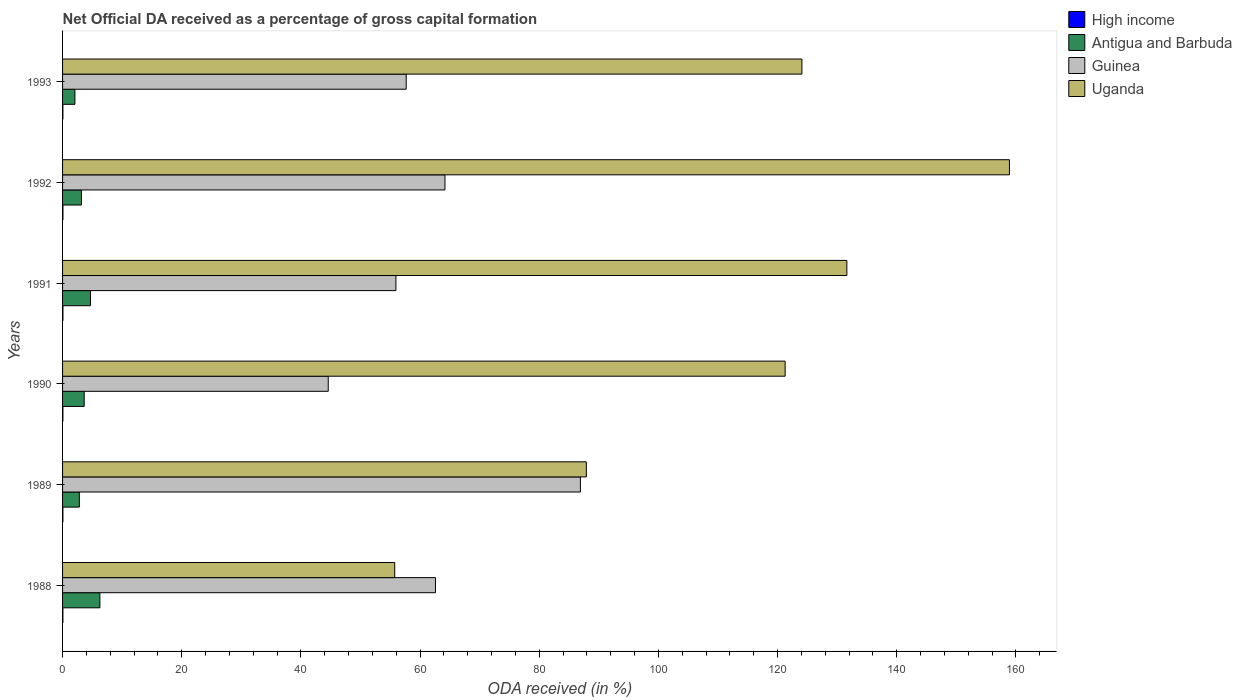How many different coloured bars are there?
Ensure brevity in your answer.  4. Are the number of bars per tick equal to the number of legend labels?
Provide a succinct answer. Yes. Are the number of bars on each tick of the Y-axis equal?
Give a very brief answer. Yes. How many bars are there on the 5th tick from the bottom?
Keep it short and to the point. 4. What is the net ODA received in High income in 1990?
Your answer should be very brief. 0.06. Across all years, what is the maximum net ODA received in Antigua and Barbuda?
Make the answer very short. 6.26. Across all years, what is the minimum net ODA received in Antigua and Barbuda?
Offer a very short reply. 2.07. In which year was the net ODA received in Uganda maximum?
Your answer should be very brief. 1992. What is the total net ODA received in High income in the graph?
Provide a short and direct response. 0.35. What is the difference between the net ODA received in Uganda in 1990 and that in 1992?
Offer a terse response. -37.64. What is the difference between the net ODA received in Antigua and Barbuda in 1993 and the net ODA received in Uganda in 1989?
Your answer should be compact. -85.83. What is the average net ODA received in Uganda per year?
Offer a very short reply. 113.25. In the year 1993, what is the difference between the net ODA received in Uganda and net ODA received in Antigua and Barbuda?
Provide a short and direct response. 122. In how many years, is the net ODA received in Antigua and Barbuda greater than 100 %?
Provide a succinct answer. 0. What is the ratio of the net ODA received in High income in 1988 to that in 1991?
Offer a very short reply. 0.93. What is the difference between the highest and the second highest net ODA received in Antigua and Barbuda?
Ensure brevity in your answer.  1.58. What is the difference between the highest and the lowest net ODA received in Antigua and Barbuda?
Make the answer very short. 4.19. Is the sum of the net ODA received in Guinea in 1989 and 1993 greater than the maximum net ODA received in Uganda across all years?
Give a very brief answer. No. Is it the case that in every year, the sum of the net ODA received in Uganda and net ODA received in Antigua and Barbuda is greater than the sum of net ODA received in High income and net ODA received in Guinea?
Provide a succinct answer. Yes. What does the 2nd bar from the top in 1989 represents?
Your response must be concise. Guinea. Is it the case that in every year, the sum of the net ODA received in Guinea and net ODA received in Uganda is greater than the net ODA received in High income?
Your answer should be compact. Yes. Are all the bars in the graph horizontal?
Give a very brief answer. Yes. What is the difference between two consecutive major ticks on the X-axis?
Your answer should be compact. 20. Are the values on the major ticks of X-axis written in scientific E-notation?
Offer a terse response. No. Does the graph contain any zero values?
Your response must be concise. No. Where does the legend appear in the graph?
Your answer should be compact. Top right. How many legend labels are there?
Your response must be concise. 4. What is the title of the graph?
Provide a succinct answer. Net Official DA received as a percentage of gross capital formation. What is the label or title of the X-axis?
Keep it short and to the point. ODA received (in %). What is the label or title of the Y-axis?
Offer a terse response. Years. What is the ODA received (in %) of High income in 1988?
Your answer should be compact. 0.06. What is the ODA received (in %) of Antigua and Barbuda in 1988?
Your response must be concise. 6.26. What is the ODA received (in %) in Guinea in 1988?
Your answer should be compact. 62.58. What is the ODA received (in %) in Uganda in 1988?
Offer a very short reply. 55.74. What is the ODA received (in %) in High income in 1989?
Ensure brevity in your answer.  0.06. What is the ODA received (in %) in Antigua and Barbuda in 1989?
Your answer should be compact. 2.82. What is the ODA received (in %) of Guinea in 1989?
Your answer should be compact. 86.9. What is the ODA received (in %) in Uganda in 1989?
Provide a succinct answer. 87.9. What is the ODA received (in %) in High income in 1990?
Your answer should be very brief. 0.06. What is the ODA received (in %) in Antigua and Barbuda in 1990?
Offer a terse response. 3.63. What is the ODA received (in %) of Guinea in 1990?
Make the answer very short. 44.58. What is the ODA received (in %) in Uganda in 1990?
Provide a short and direct response. 121.26. What is the ODA received (in %) in High income in 1991?
Make the answer very short. 0.06. What is the ODA received (in %) of Antigua and Barbuda in 1991?
Your answer should be very brief. 4.68. What is the ODA received (in %) in Guinea in 1991?
Your answer should be compact. 55.94. What is the ODA received (in %) of Uganda in 1991?
Offer a very short reply. 131.62. What is the ODA received (in %) in High income in 1992?
Provide a short and direct response. 0.06. What is the ODA received (in %) in Antigua and Barbuda in 1992?
Your response must be concise. 3.17. What is the ODA received (in %) of Guinea in 1992?
Provide a short and direct response. 64.17. What is the ODA received (in %) in Uganda in 1992?
Offer a very short reply. 158.9. What is the ODA received (in %) of High income in 1993?
Your answer should be compact. 0.06. What is the ODA received (in %) of Antigua and Barbuda in 1993?
Provide a short and direct response. 2.07. What is the ODA received (in %) in Guinea in 1993?
Your answer should be very brief. 57.67. What is the ODA received (in %) of Uganda in 1993?
Provide a succinct answer. 124.08. Across all years, what is the maximum ODA received (in %) of High income?
Make the answer very short. 0.06. Across all years, what is the maximum ODA received (in %) of Antigua and Barbuda?
Your response must be concise. 6.26. Across all years, what is the maximum ODA received (in %) of Guinea?
Make the answer very short. 86.9. Across all years, what is the maximum ODA received (in %) of Uganda?
Your answer should be compact. 158.9. Across all years, what is the minimum ODA received (in %) of High income?
Make the answer very short. 0.06. Across all years, what is the minimum ODA received (in %) of Antigua and Barbuda?
Your response must be concise. 2.07. Across all years, what is the minimum ODA received (in %) in Guinea?
Keep it short and to the point. 44.58. Across all years, what is the minimum ODA received (in %) in Uganda?
Provide a succinct answer. 55.74. What is the total ODA received (in %) in High income in the graph?
Offer a terse response. 0.35. What is the total ODA received (in %) of Antigua and Barbuda in the graph?
Give a very brief answer. 22.64. What is the total ODA received (in %) of Guinea in the graph?
Keep it short and to the point. 371.85. What is the total ODA received (in %) of Uganda in the graph?
Offer a very short reply. 679.5. What is the difference between the ODA received (in %) in High income in 1988 and that in 1989?
Give a very brief answer. 0. What is the difference between the ODA received (in %) of Antigua and Barbuda in 1988 and that in 1989?
Ensure brevity in your answer.  3.44. What is the difference between the ODA received (in %) of Guinea in 1988 and that in 1989?
Offer a terse response. -24.32. What is the difference between the ODA received (in %) in Uganda in 1988 and that in 1989?
Provide a short and direct response. -32.15. What is the difference between the ODA received (in %) of High income in 1988 and that in 1990?
Make the answer very short. -0. What is the difference between the ODA received (in %) in Antigua and Barbuda in 1988 and that in 1990?
Ensure brevity in your answer.  2.63. What is the difference between the ODA received (in %) of Guinea in 1988 and that in 1990?
Provide a short and direct response. 18. What is the difference between the ODA received (in %) of Uganda in 1988 and that in 1990?
Your response must be concise. -65.52. What is the difference between the ODA received (in %) of High income in 1988 and that in 1991?
Provide a short and direct response. -0. What is the difference between the ODA received (in %) in Antigua and Barbuda in 1988 and that in 1991?
Your answer should be compact. 1.58. What is the difference between the ODA received (in %) of Guinea in 1988 and that in 1991?
Your answer should be compact. 6.64. What is the difference between the ODA received (in %) in Uganda in 1988 and that in 1991?
Your answer should be compact. -75.87. What is the difference between the ODA received (in %) in High income in 1988 and that in 1992?
Your answer should be compact. -0.01. What is the difference between the ODA received (in %) in Antigua and Barbuda in 1988 and that in 1992?
Provide a short and direct response. 3.1. What is the difference between the ODA received (in %) in Guinea in 1988 and that in 1992?
Give a very brief answer. -1.59. What is the difference between the ODA received (in %) of Uganda in 1988 and that in 1992?
Your answer should be very brief. -103.16. What is the difference between the ODA received (in %) of High income in 1988 and that in 1993?
Your answer should be very brief. -0. What is the difference between the ODA received (in %) in Antigua and Barbuda in 1988 and that in 1993?
Your response must be concise. 4.19. What is the difference between the ODA received (in %) of Guinea in 1988 and that in 1993?
Your answer should be very brief. 4.91. What is the difference between the ODA received (in %) of Uganda in 1988 and that in 1993?
Your response must be concise. -68.33. What is the difference between the ODA received (in %) of High income in 1989 and that in 1990?
Your answer should be compact. -0. What is the difference between the ODA received (in %) in Antigua and Barbuda in 1989 and that in 1990?
Your response must be concise. -0.81. What is the difference between the ODA received (in %) in Guinea in 1989 and that in 1990?
Give a very brief answer. 42.32. What is the difference between the ODA received (in %) in Uganda in 1989 and that in 1990?
Provide a short and direct response. -33.36. What is the difference between the ODA received (in %) of High income in 1989 and that in 1991?
Make the answer very short. -0.01. What is the difference between the ODA received (in %) of Antigua and Barbuda in 1989 and that in 1991?
Provide a succinct answer. -1.87. What is the difference between the ODA received (in %) in Guinea in 1989 and that in 1991?
Ensure brevity in your answer.  30.96. What is the difference between the ODA received (in %) in Uganda in 1989 and that in 1991?
Keep it short and to the point. -43.72. What is the difference between the ODA received (in %) in High income in 1989 and that in 1992?
Give a very brief answer. -0.01. What is the difference between the ODA received (in %) in Antigua and Barbuda in 1989 and that in 1992?
Offer a very short reply. -0.35. What is the difference between the ODA received (in %) in Guinea in 1989 and that in 1992?
Offer a very short reply. 22.73. What is the difference between the ODA received (in %) in Uganda in 1989 and that in 1992?
Your response must be concise. -71. What is the difference between the ODA received (in %) of High income in 1989 and that in 1993?
Provide a short and direct response. -0. What is the difference between the ODA received (in %) in Antigua and Barbuda in 1989 and that in 1993?
Offer a terse response. 0.74. What is the difference between the ODA received (in %) in Guinea in 1989 and that in 1993?
Ensure brevity in your answer.  29.23. What is the difference between the ODA received (in %) of Uganda in 1989 and that in 1993?
Your answer should be very brief. -36.18. What is the difference between the ODA received (in %) in High income in 1990 and that in 1991?
Offer a very short reply. -0. What is the difference between the ODA received (in %) in Antigua and Barbuda in 1990 and that in 1991?
Your answer should be very brief. -1.06. What is the difference between the ODA received (in %) of Guinea in 1990 and that in 1991?
Ensure brevity in your answer.  -11.36. What is the difference between the ODA received (in %) in Uganda in 1990 and that in 1991?
Your answer should be compact. -10.36. What is the difference between the ODA received (in %) of High income in 1990 and that in 1992?
Provide a succinct answer. -0.01. What is the difference between the ODA received (in %) in Antigua and Barbuda in 1990 and that in 1992?
Your answer should be compact. 0.46. What is the difference between the ODA received (in %) in Guinea in 1990 and that in 1992?
Offer a very short reply. -19.59. What is the difference between the ODA received (in %) of Uganda in 1990 and that in 1992?
Offer a very short reply. -37.64. What is the difference between the ODA received (in %) of Antigua and Barbuda in 1990 and that in 1993?
Your answer should be very brief. 1.56. What is the difference between the ODA received (in %) in Guinea in 1990 and that in 1993?
Your answer should be very brief. -13.09. What is the difference between the ODA received (in %) in Uganda in 1990 and that in 1993?
Ensure brevity in your answer.  -2.81. What is the difference between the ODA received (in %) of High income in 1991 and that in 1992?
Ensure brevity in your answer.  -0. What is the difference between the ODA received (in %) in Antigua and Barbuda in 1991 and that in 1992?
Provide a succinct answer. 1.52. What is the difference between the ODA received (in %) in Guinea in 1991 and that in 1992?
Your answer should be very brief. -8.23. What is the difference between the ODA received (in %) in Uganda in 1991 and that in 1992?
Keep it short and to the point. -27.29. What is the difference between the ODA received (in %) of High income in 1991 and that in 1993?
Make the answer very short. 0. What is the difference between the ODA received (in %) in Antigua and Barbuda in 1991 and that in 1993?
Your response must be concise. 2.61. What is the difference between the ODA received (in %) in Guinea in 1991 and that in 1993?
Make the answer very short. -1.73. What is the difference between the ODA received (in %) in Uganda in 1991 and that in 1993?
Give a very brief answer. 7.54. What is the difference between the ODA received (in %) in High income in 1992 and that in 1993?
Keep it short and to the point. 0.01. What is the difference between the ODA received (in %) in Antigua and Barbuda in 1992 and that in 1993?
Keep it short and to the point. 1.09. What is the difference between the ODA received (in %) of Guinea in 1992 and that in 1993?
Provide a succinct answer. 6.5. What is the difference between the ODA received (in %) in Uganda in 1992 and that in 1993?
Your response must be concise. 34.83. What is the difference between the ODA received (in %) in High income in 1988 and the ODA received (in %) in Antigua and Barbuda in 1989?
Keep it short and to the point. -2.76. What is the difference between the ODA received (in %) in High income in 1988 and the ODA received (in %) in Guinea in 1989?
Your answer should be compact. -86.85. What is the difference between the ODA received (in %) of High income in 1988 and the ODA received (in %) of Uganda in 1989?
Provide a succinct answer. -87.84. What is the difference between the ODA received (in %) of Antigua and Barbuda in 1988 and the ODA received (in %) of Guinea in 1989?
Give a very brief answer. -80.64. What is the difference between the ODA received (in %) in Antigua and Barbuda in 1988 and the ODA received (in %) in Uganda in 1989?
Make the answer very short. -81.64. What is the difference between the ODA received (in %) in Guinea in 1988 and the ODA received (in %) in Uganda in 1989?
Give a very brief answer. -25.32. What is the difference between the ODA received (in %) in High income in 1988 and the ODA received (in %) in Antigua and Barbuda in 1990?
Provide a short and direct response. -3.57. What is the difference between the ODA received (in %) in High income in 1988 and the ODA received (in %) in Guinea in 1990?
Give a very brief answer. -44.53. What is the difference between the ODA received (in %) of High income in 1988 and the ODA received (in %) of Uganda in 1990?
Provide a short and direct response. -121.2. What is the difference between the ODA received (in %) of Antigua and Barbuda in 1988 and the ODA received (in %) of Guinea in 1990?
Your answer should be very brief. -38.32. What is the difference between the ODA received (in %) of Antigua and Barbuda in 1988 and the ODA received (in %) of Uganda in 1990?
Provide a succinct answer. -115. What is the difference between the ODA received (in %) of Guinea in 1988 and the ODA received (in %) of Uganda in 1990?
Provide a succinct answer. -58.68. What is the difference between the ODA received (in %) in High income in 1988 and the ODA received (in %) in Antigua and Barbuda in 1991?
Offer a very short reply. -4.63. What is the difference between the ODA received (in %) of High income in 1988 and the ODA received (in %) of Guinea in 1991?
Ensure brevity in your answer.  -55.88. What is the difference between the ODA received (in %) in High income in 1988 and the ODA received (in %) in Uganda in 1991?
Give a very brief answer. -131.56. What is the difference between the ODA received (in %) of Antigua and Barbuda in 1988 and the ODA received (in %) of Guinea in 1991?
Your answer should be compact. -49.68. What is the difference between the ODA received (in %) of Antigua and Barbuda in 1988 and the ODA received (in %) of Uganda in 1991?
Offer a very short reply. -125.35. What is the difference between the ODA received (in %) of Guinea in 1988 and the ODA received (in %) of Uganda in 1991?
Your response must be concise. -69.04. What is the difference between the ODA received (in %) in High income in 1988 and the ODA received (in %) in Antigua and Barbuda in 1992?
Offer a terse response. -3.11. What is the difference between the ODA received (in %) of High income in 1988 and the ODA received (in %) of Guinea in 1992?
Give a very brief answer. -64.11. What is the difference between the ODA received (in %) in High income in 1988 and the ODA received (in %) in Uganda in 1992?
Your answer should be compact. -158.85. What is the difference between the ODA received (in %) in Antigua and Barbuda in 1988 and the ODA received (in %) in Guinea in 1992?
Provide a short and direct response. -57.91. What is the difference between the ODA received (in %) of Antigua and Barbuda in 1988 and the ODA received (in %) of Uganda in 1992?
Offer a terse response. -152.64. What is the difference between the ODA received (in %) of Guinea in 1988 and the ODA received (in %) of Uganda in 1992?
Provide a succinct answer. -96.32. What is the difference between the ODA received (in %) in High income in 1988 and the ODA received (in %) in Antigua and Barbuda in 1993?
Provide a short and direct response. -2.02. What is the difference between the ODA received (in %) in High income in 1988 and the ODA received (in %) in Guinea in 1993?
Offer a very short reply. -57.61. What is the difference between the ODA received (in %) of High income in 1988 and the ODA received (in %) of Uganda in 1993?
Your answer should be compact. -124.02. What is the difference between the ODA received (in %) in Antigua and Barbuda in 1988 and the ODA received (in %) in Guinea in 1993?
Make the answer very short. -51.41. What is the difference between the ODA received (in %) in Antigua and Barbuda in 1988 and the ODA received (in %) in Uganda in 1993?
Your response must be concise. -117.81. What is the difference between the ODA received (in %) of Guinea in 1988 and the ODA received (in %) of Uganda in 1993?
Offer a terse response. -61.5. What is the difference between the ODA received (in %) of High income in 1989 and the ODA received (in %) of Antigua and Barbuda in 1990?
Provide a short and direct response. -3.57. What is the difference between the ODA received (in %) of High income in 1989 and the ODA received (in %) of Guinea in 1990?
Your response must be concise. -44.53. What is the difference between the ODA received (in %) of High income in 1989 and the ODA received (in %) of Uganda in 1990?
Ensure brevity in your answer.  -121.21. What is the difference between the ODA received (in %) of Antigua and Barbuda in 1989 and the ODA received (in %) of Guinea in 1990?
Give a very brief answer. -41.77. What is the difference between the ODA received (in %) of Antigua and Barbuda in 1989 and the ODA received (in %) of Uganda in 1990?
Give a very brief answer. -118.44. What is the difference between the ODA received (in %) of Guinea in 1989 and the ODA received (in %) of Uganda in 1990?
Provide a succinct answer. -34.36. What is the difference between the ODA received (in %) of High income in 1989 and the ODA received (in %) of Antigua and Barbuda in 1991?
Offer a very short reply. -4.63. What is the difference between the ODA received (in %) in High income in 1989 and the ODA received (in %) in Guinea in 1991?
Offer a very short reply. -55.88. What is the difference between the ODA received (in %) of High income in 1989 and the ODA received (in %) of Uganda in 1991?
Provide a short and direct response. -131.56. What is the difference between the ODA received (in %) of Antigua and Barbuda in 1989 and the ODA received (in %) of Guinea in 1991?
Ensure brevity in your answer.  -53.12. What is the difference between the ODA received (in %) of Antigua and Barbuda in 1989 and the ODA received (in %) of Uganda in 1991?
Make the answer very short. -128.8. What is the difference between the ODA received (in %) in Guinea in 1989 and the ODA received (in %) in Uganda in 1991?
Give a very brief answer. -44.71. What is the difference between the ODA received (in %) in High income in 1989 and the ODA received (in %) in Antigua and Barbuda in 1992?
Offer a very short reply. -3.11. What is the difference between the ODA received (in %) of High income in 1989 and the ODA received (in %) of Guinea in 1992?
Keep it short and to the point. -64.12. What is the difference between the ODA received (in %) of High income in 1989 and the ODA received (in %) of Uganda in 1992?
Provide a short and direct response. -158.85. What is the difference between the ODA received (in %) in Antigua and Barbuda in 1989 and the ODA received (in %) in Guinea in 1992?
Your answer should be very brief. -61.35. What is the difference between the ODA received (in %) of Antigua and Barbuda in 1989 and the ODA received (in %) of Uganda in 1992?
Give a very brief answer. -156.09. What is the difference between the ODA received (in %) of Guinea in 1989 and the ODA received (in %) of Uganda in 1992?
Keep it short and to the point. -72. What is the difference between the ODA received (in %) in High income in 1989 and the ODA received (in %) in Antigua and Barbuda in 1993?
Offer a terse response. -2.02. What is the difference between the ODA received (in %) in High income in 1989 and the ODA received (in %) in Guinea in 1993?
Offer a very short reply. -57.61. What is the difference between the ODA received (in %) of High income in 1989 and the ODA received (in %) of Uganda in 1993?
Offer a terse response. -124.02. What is the difference between the ODA received (in %) of Antigua and Barbuda in 1989 and the ODA received (in %) of Guinea in 1993?
Your answer should be very brief. -54.85. What is the difference between the ODA received (in %) of Antigua and Barbuda in 1989 and the ODA received (in %) of Uganda in 1993?
Offer a terse response. -121.26. What is the difference between the ODA received (in %) in Guinea in 1989 and the ODA received (in %) in Uganda in 1993?
Give a very brief answer. -37.17. What is the difference between the ODA received (in %) of High income in 1990 and the ODA received (in %) of Antigua and Barbuda in 1991?
Make the answer very short. -4.63. What is the difference between the ODA received (in %) in High income in 1990 and the ODA received (in %) in Guinea in 1991?
Offer a very short reply. -55.88. What is the difference between the ODA received (in %) of High income in 1990 and the ODA received (in %) of Uganda in 1991?
Provide a succinct answer. -131.56. What is the difference between the ODA received (in %) in Antigua and Barbuda in 1990 and the ODA received (in %) in Guinea in 1991?
Ensure brevity in your answer.  -52.31. What is the difference between the ODA received (in %) in Antigua and Barbuda in 1990 and the ODA received (in %) in Uganda in 1991?
Offer a very short reply. -127.99. What is the difference between the ODA received (in %) in Guinea in 1990 and the ODA received (in %) in Uganda in 1991?
Your answer should be compact. -87.03. What is the difference between the ODA received (in %) of High income in 1990 and the ODA received (in %) of Antigua and Barbuda in 1992?
Make the answer very short. -3.11. What is the difference between the ODA received (in %) in High income in 1990 and the ODA received (in %) in Guinea in 1992?
Keep it short and to the point. -64.11. What is the difference between the ODA received (in %) of High income in 1990 and the ODA received (in %) of Uganda in 1992?
Ensure brevity in your answer.  -158.85. What is the difference between the ODA received (in %) in Antigua and Barbuda in 1990 and the ODA received (in %) in Guinea in 1992?
Offer a terse response. -60.54. What is the difference between the ODA received (in %) in Antigua and Barbuda in 1990 and the ODA received (in %) in Uganda in 1992?
Make the answer very short. -155.27. What is the difference between the ODA received (in %) of Guinea in 1990 and the ODA received (in %) of Uganda in 1992?
Provide a succinct answer. -114.32. What is the difference between the ODA received (in %) of High income in 1990 and the ODA received (in %) of Antigua and Barbuda in 1993?
Provide a short and direct response. -2.02. What is the difference between the ODA received (in %) of High income in 1990 and the ODA received (in %) of Guinea in 1993?
Your answer should be very brief. -57.61. What is the difference between the ODA received (in %) of High income in 1990 and the ODA received (in %) of Uganda in 1993?
Provide a succinct answer. -124.02. What is the difference between the ODA received (in %) in Antigua and Barbuda in 1990 and the ODA received (in %) in Guinea in 1993?
Your response must be concise. -54.04. What is the difference between the ODA received (in %) in Antigua and Barbuda in 1990 and the ODA received (in %) in Uganda in 1993?
Provide a short and direct response. -120.45. What is the difference between the ODA received (in %) of Guinea in 1990 and the ODA received (in %) of Uganda in 1993?
Offer a very short reply. -79.49. What is the difference between the ODA received (in %) in High income in 1991 and the ODA received (in %) in Antigua and Barbuda in 1992?
Your answer should be very brief. -3.11. What is the difference between the ODA received (in %) of High income in 1991 and the ODA received (in %) of Guinea in 1992?
Your answer should be compact. -64.11. What is the difference between the ODA received (in %) in High income in 1991 and the ODA received (in %) in Uganda in 1992?
Keep it short and to the point. -158.84. What is the difference between the ODA received (in %) in Antigua and Barbuda in 1991 and the ODA received (in %) in Guinea in 1992?
Make the answer very short. -59.49. What is the difference between the ODA received (in %) in Antigua and Barbuda in 1991 and the ODA received (in %) in Uganda in 1992?
Offer a very short reply. -154.22. What is the difference between the ODA received (in %) in Guinea in 1991 and the ODA received (in %) in Uganda in 1992?
Offer a very short reply. -102.96. What is the difference between the ODA received (in %) in High income in 1991 and the ODA received (in %) in Antigua and Barbuda in 1993?
Your answer should be compact. -2.01. What is the difference between the ODA received (in %) in High income in 1991 and the ODA received (in %) in Guinea in 1993?
Offer a terse response. -57.61. What is the difference between the ODA received (in %) of High income in 1991 and the ODA received (in %) of Uganda in 1993?
Your answer should be very brief. -124.01. What is the difference between the ODA received (in %) of Antigua and Barbuda in 1991 and the ODA received (in %) of Guinea in 1993?
Offer a terse response. -52.99. What is the difference between the ODA received (in %) of Antigua and Barbuda in 1991 and the ODA received (in %) of Uganda in 1993?
Your response must be concise. -119.39. What is the difference between the ODA received (in %) of Guinea in 1991 and the ODA received (in %) of Uganda in 1993?
Provide a short and direct response. -68.14. What is the difference between the ODA received (in %) of High income in 1992 and the ODA received (in %) of Antigua and Barbuda in 1993?
Offer a very short reply. -2.01. What is the difference between the ODA received (in %) of High income in 1992 and the ODA received (in %) of Guinea in 1993?
Offer a very short reply. -57.6. What is the difference between the ODA received (in %) in High income in 1992 and the ODA received (in %) in Uganda in 1993?
Offer a terse response. -124.01. What is the difference between the ODA received (in %) in Antigua and Barbuda in 1992 and the ODA received (in %) in Guinea in 1993?
Your answer should be very brief. -54.5. What is the difference between the ODA received (in %) of Antigua and Barbuda in 1992 and the ODA received (in %) of Uganda in 1993?
Keep it short and to the point. -120.91. What is the difference between the ODA received (in %) of Guinea in 1992 and the ODA received (in %) of Uganda in 1993?
Your answer should be very brief. -59.9. What is the average ODA received (in %) of High income per year?
Offer a terse response. 0.06. What is the average ODA received (in %) of Antigua and Barbuda per year?
Keep it short and to the point. 3.77. What is the average ODA received (in %) of Guinea per year?
Make the answer very short. 61.97. What is the average ODA received (in %) in Uganda per year?
Offer a terse response. 113.25. In the year 1988, what is the difference between the ODA received (in %) of High income and ODA received (in %) of Antigua and Barbuda?
Give a very brief answer. -6.21. In the year 1988, what is the difference between the ODA received (in %) of High income and ODA received (in %) of Guinea?
Provide a short and direct response. -62.52. In the year 1988, what is the difference between the ODA received (in %) of High income and ODA received (in %) of Uganda?
Provide a short and direct response. -55.69. In the year 1988, what is the difference between the ODA received (in %) of Antigua and Barbuda and ODA received (in %) of Guinea?
Keep it short and to the point. -56.32. In the year 1988, what is the difference between the ODA received (in %) of Antigua and Barbuda and ODA received (in %) of Uganda?
Provide a succinct answer. -49.48. In the year 1988, what is the difference between the ODA received (in %) of Guinea and ODA received (in %) of Uganda?
Ensure brevity in your answer.  6.84. In the year 1989, what is the difference between the ODA received (in %) of High income and ODA received (in %) of Antigua and Barbuda?
Keep it short and to the point. -2.76. In the year 1989, what is the difference between the ODA received (in %) of High income and ODA received (in %) of Guinea?
Keep it short and to the point. -86.85. In the year 1989, what is the difference between the ODA received (in %) in High income and ODA received (in %) in Uganda?
Provide a short and direct response. -87.84. In the year 1989, what is the difference between the ODA received (in %) in Antigua and Barbuda and ODA received (in %) in Guinea?
Your answer should be very brief. -84.08. In the year 1989, what is the difference between the ODA received (in %) of Antigua and Barbuda and ODA received (in %) of Uganda?
Offer a very short reply. -85.08. In the year 1989, what is the difference between the ODA received (in %) of Guinea and ODA received (in %) of Uganda?
Keep it short and to the point. -1. In the year 1990, what is the difference between the ODA received (in %) in High income and ODA received (in %) in Antigua and Barbuda?
Provide a short and direct response. -3.57. In the year 1990, what is the difference between the ODA received (in %) in High income and ODA received (in %) in Guinea?
Offer a terse response. -44.53. In the year 1990, what is the difference between the ODA received (in %) of High income and ODA received (in %) of Uganda?
Offer a very short reply. -121.2. In the year 1990, what is the difference between the ODA received (in %) in Antigua and Barbuda and ODA received (in %) in Guinea?
Keep it short and to the point. -40.95. In the year 1990, what is the difference between the ODA received (in %) of Antigua and Barbuda and ODA received (in %) of Uganda?
Your response must be concise. -117.63. In the year 1990, what is the difference between the ODA received (in %) in Guinea and ODA received (in %) in Uganda?
Make the answer very short. -76.68. In the year 1991, what is the difference between the ODA received (in %) in High income and ODA received (in %) in Antigua and Barbuda?
Provide a short and direct response. -4.62. In the year 1991, what is the difference between the ODA received (in %) in High income and ODA received (in %) in Guinea?
Provide a short and direct response. -55.88. In the year 1991, what is the difference between the ODA received (in %) of High income and ODA received (in %) of Uganda?
Keep it short and to the point. -131.56. In the year 1991, what is the difference between the ODA received (in %) in Antigua and Barbuda and ODA received (in %) in Guinea?
Give a very brief answer. -51.26. In the year 1991, what is the difference between the ODA received (in %) in Antigua and Barbuda and ODA received (in %) in Uganda?
Give a very brief answer. -126.93. In the year 1991, what is the difference between the ODA received (in %) in Guinea and ODA received (in %) in Uganda?
Provide a succinct answer. -75.68. In the year 1992, what is the difference between the ODA received (in %) in High income and ODA received (in %) in Antigua and Barbuda?
Ensure brevity in your answer.  -3.1. In the year 1992, what is the difference between the ODA received (in %) in High income and ODA received (in %) in Guinea?
Your response must be concise. -64.11. In the year 1992, what is the difference between the ODA received (in %) of High income and ODA received (in %) of Uganda?
Your answer should be very brief. -158.84. In the year 1992, what is the difference between the ODA received (in %) in Antigua and Barbuda and ODA received (in %) in Guinea?
Your response must be concise. -61. In the year 1992, what is the difference between the ODA received (in %) in Antigua and Barbuda and ODA received (in %) in Uganda?
Provide a succinct answer. -155.74. In the year 1992, what is the difference between the ODA received (in %) of Guinea and ODA received (in %) of Uganda?
Your response must be concise. -94.73. In the year 1993, what is the difference between the ODA received (in %) of High income and ODA received (in %) of Antigua and Barbuda?
Keep it short and to the point. -2.02. In the year 1993, what is the difference between the ODA received (in %) of High income and ODA received (in %) of Guinea?
Provide a succinct answer. -57.61. In the year 1993, what is the difference between the ODA received (in %) in High income and ODA received (in %) in Uganda?
Offer a very short reply. -124.02. In the year 1993, what is the difference between the ODA received (in %) in Antigua and Barbuda and ODA received (in %) in Guinea?
Make the answer very short. -55.6. In the year 1993, what is the difference between the ODA received (in %) in Antigua and Barbuda and ODA received (in %) in Uganda?
Offer a terse response. -122. In the year 1993, what is the difference between the ODA received (in %) of Guinea and ODA received (in %) of Uganda?
Offer a terse response. -66.41. What is the ratio of the ODA received (in %) of High income in 1988 to that in 1989?
Ensure brevity in your answer.  1.01. What is the ratio of the ODA received (in %) of Antigua and Barbuda in 1988 to that in 1989?
Provide a short and direct response. 2.22. What is the ratio of the ODA received (in %) of Guinea in 1988 to that in 1989?
Your answer should be compact. 0.72. What is the ratio of the ODA received (in %) in Uganda in 1988 to that in 1989?
Your answer should be compact. 0.63. What is the ratio of the ODA received (in %) of High income in 1988 to that in 1990?
Provide a succinct answer. 0.98. What is the ratio of the ODA received (in %) of Antigua and Barbuda in 1988 to that in 1990?
Give a very brief answer. 1.73. What is the ratio of the ODA received (in %) in Guinea in 1988 to that in 1990?
Your answer should be compact. 1.4. What is the ratio of the ODA received (in %) in Uganda in 1988 to that in 1990?
Offer a very short reply. 0.46. What is the ratio of the ODA received (in %) of High income in 1988 to that in 1991?
Ensure brevity in your answer.  0.93. What is the ratio of the ODA received (in %) in Antigua and Barbuda in 1988 to that in 1991?
Offer a very short reply. 1.34. What is the ratio of the ODA received (in %) in Guinea in 1988 to that in 1991?
Your response must be concise. 1.12. What is the ratio of the ODA received (in %) of Uganda in 1988 to that in 1991?
Provide a succinct answer. 0.42. What is the ratio of the ODA received (in %) in High income in 1988 to that in 1992?
Your response must be concise. 0.88. What is the ratio of the ODA received (in %) of Antigua and Barbuda in 1988 to that in 1992?
Your response must be concise. 1.98. What is the ratio of the ODA received (in %) of Guinea in 1988 to that in 1992?
Provide a short and direct response. 0.98. What is the ratio of the ODA received (in %) in Uganda in 1988 to that in 1992?
Make the answer very short. 0.35. What is the ratio of the ODA received (in %) of High income in 1988 to that in 1993?
Your answer should be compact. 0.99. What is the ratio of the ODA received (in %) of Antigua and Barbuda in 1988 to that in 1993?
Provide a succinct answer. 3.02. What is the ratio of the ODA received (in %) in Guinea in 1988 to that in 1993?
Provide a short and direct response. 1.09. What is the ratio of the ODA received (in %) in Uganda in 1988 to that in 1993?
Give a very brief answer. 0.45. What is the ratio of the ODA received (in %) in High income in 1989 to that in 1990?
Give a very brief answer. 0.97. What is the ratio of the ODA received (in %) of Antigua and Barbuda in 1989 to that in 1990?
Provide a succinct answer. 0.78. What is the ratio of the ODA received (in %) in Guinea in 1989 to that in 1990?
Provide a short and direct response. 1.95. What is the ratio of the ODA received (in %) of Uganda in 1989 to that in 1990?
Provide a succinct answer. 0.72. What is the ratio of the ODA received (in %) of High income in 1989 to that in 1991?
Offer a terse response. 0.92. What is the ratio of the ODA received (in %) in Antigua and Barbuda in 1989 to that in 1991?
Your answer should be very brief. 0.6. What is the ratio of the ODA received (in %) of Guinea in 1989 to that in 1991?
Ensure brevity in your answer.  1.55. What is the ratio of the ODA received (in %) of Uganda in 1989 to that in 1991?
Your answer should be very brief. 0.67. What is the ratio of the ODA received (in %) of High income in 1989 to that in 1992?
Ensure brevity in your answer.  0.87. What is the ratio of the ODA received (in %) in Antigua and Barbuda in 1989 to that in 1992?
Ensure brevity in your answer.  0.89. What is the ratio of the ODA received (in %) in Guinea in 1989 to that in 1992?
Make the answer very short. 1.35. What is the ratio of the ODA received (in %) of Uganda in 1989 to that in 1992?
Provide a short and direct response. 0.55. What is the ratio of the ODA received (in %) in High income in 1989 to that in 1993?
Ensure brevity in your answer.  0.98. What is the ratio of the ODA received (in %) in Antigua and Barbuda in 1989 to that in 1993?
Offer a terse response. 1.36. What is the ratio of the ODA received (in %) in Guinea in 1989 to that in 1993?
Your answer should be compact. 1.51. What is the ratio of the ODA received (in %) of Uganda in 1989 to that in 1993?
Your response must be concise. 0.71. What is the ratio of the ODA received (in %) of High income in 1990 to that in 1991?
Your answer should be very brief. 0.94. What is the ratio of the ODA received (in %) of Antigua and Barbuda in 1990 to that in 1991?
Your answer should be very brief. 0.77. What is the ratio of the ODA received (in %) in Guinea in 1990 to that in 1991?
Provide a short and direct response. 0.8. What is the ratio of the ODA received (in %) of Uganda in 1990 to that in 1991?
Offer a very short reply. 0.92. What is the ratio of the ODA received (in %) of High income in 1990 to that in 1992?
Give a very brief answer. 0.89. What is the ratio of the ODA received (in %) of Antigua and Barbuda in 1990 to that in 1992?
Your response must be concise. 1.15. What is the ratio of the ODA received (in %) of Guinea in 1990 to that in 1992?
Provide a succinct answer. 0.69. What is the ratio of the ODA received (in %) of Uganda in 1990 to that in 1992?
Make the answer very short. 0.76. What is the ratio of the ODA received (in %) in Antigua and Barbuda in 1990 to that in 1993?
Give a very brief answer. 1.75. What is the ratio of the ODA received (in %) in Guinea in 1990 to that in 1993?
Your answer should be compact. 0.77. What is the ratio of the ODA received (in %) in Uganda in 1990 to that in 1993?
Your answer should be compact. 0.98. What is the ratio of the ODA received (in %) of High income in 1991 to that in 1992?
Your response must be concise. 0.95. What is the ratio of the ODA received (in %) in Antigua and Barbuda in 1991 to that in 1992?
Provide a short and direct response. 1.48. What is the ratio of the ODA received (in %) in Guinea in 1991 to that in 1992?
Give a very brief answer. 0.87. What is the ratio of the ODA received (in %) of Uganda in 1991 to that in 1992?
Your answer should be very brief. 0.83. What is the ratio of the ODA received (in %) of High income in 1991 to that in 1993?
Make the answer very short. 1.07. What is the ratio of the ODA received (in %) in Antigua and Barbuda in 1991 to that in 1993?
Your answer should be compact. 2.26. What is the ratio of the ODA received (in %) in Guinea in 1991 to that in 1993?
Give a very brief answer. 0.97. What is the ratio of the ODA received (in %) of Uganda in 1991 to that in 1993?
Provide a short and direct response. 1.06. What is the ratio of the ODA received (in %) of High income in 1992 to that in 1993?
Keep it short and to the point. 1.12. What is the ratio of the ODA received (in %) in Antigua and Barbuda in 1992 to that in 1993?
Your answer should be very brief. 1.53. What is the ratio of the ODA received (in %) in Guinea in 1992 to that in 1993?
Your answer should be very brief. 1.11. What is the ratio of the ODA received (in %) in Uganda in 1992 to that in 1993?
Your answer should be compact. 1.28. What is the difference between the highest and the second highest ODA received (in %) in High income?
Ensure brevity in your answer.  0. What is the difference between the highest and the second highest ODA received (in %) in Antigua and Barbuda?
Keep it short and to the point. 1.58. What is the difference between the highest and the second highest ODA received (in %) in Guinea?
Offer a terse response. 22.73. What is the difference between the highest and the second highest ODA received (in %) in Uganda?
Your answer should be compact. 27.29. What is the difference between the highest and the lowest ODA received (in %) of High income?
Keep it short and to the point. 0.01. What is the difference between the highest and the lowest ODA received (in %) of Antigua and Barbuda?
Keep it short and to the point. 4.19. What is the difference between the highest and the lowest ODA received (in %) in Guinea?
Your answer should be compact. 42.32. What is the difference between the highest and the lowest ODA received (in %) of Uganda?
Your response must be concise. 103.16. 